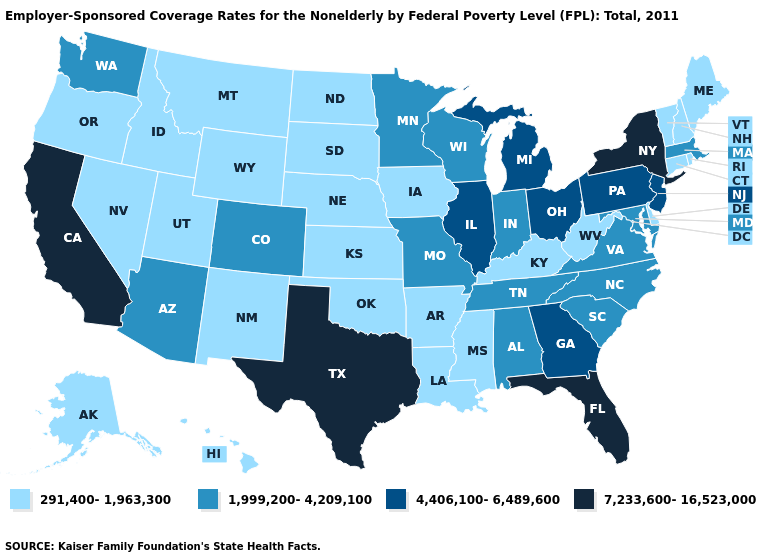Does Connecticut have the lowest value in the Northeast?
Be succinct. Yes. Name the states that have a value in the range 4,406,100-6,489,600?
Give a very brief answer. Georgia, Illinois, Michigan, New Jersey, Ohio, Pennsylvania. Does Wyoming have the lowest value in the USA?
Be succinct. Yes. What is the highest value in the West ?
Be succinct. 7,233,600-16,523,000. Which states have the highest value in the USA?
Quick response, please. California, Florida, New York, Texas. Among the states that border Colorado , which have the lowest value?
Quick response, please. Kansas, Nebraska, New Mexico, Oklahoma, Utah, Wyoming. Does Alabama have a higher value than Pennsylvania?
Be succinct. No. Which states hav the highest value in the South?
Short answer required. Florida, Texas. Which states hav the highest value in the MidWest?
Write a very short answer. Illinois, Michigan, Ohio. Does Arkansas have the highest value in the South?
Concise answer only. No. Which states have the lowest value in the West?
Quick response, please. Alaska, Hawaii, Idaho, Montana, Nevada, New Mexico, Oregon, Utah, Wyoming. What is the lowest value in states that border Kansas?
Quick response, please. 291,400-1,963,300. What is the value of Massachusetts?
Give a very brief answer. 1,999,200-4,209,100. Does Kentucky have the lowest value in the USA?
Give a very brief answer. Yes. What is the lowest value in the USA?
Give a very brief answer. 291,400-1,963,300. 